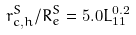<formula> <loc_0><loc_0><loc_500><loc_500>r ^ { S } _ { c , h } / R ^ { S } _ { e } = 5 . 0 L _ { 1 1 } ^ { 0 . 2 }</formula> 